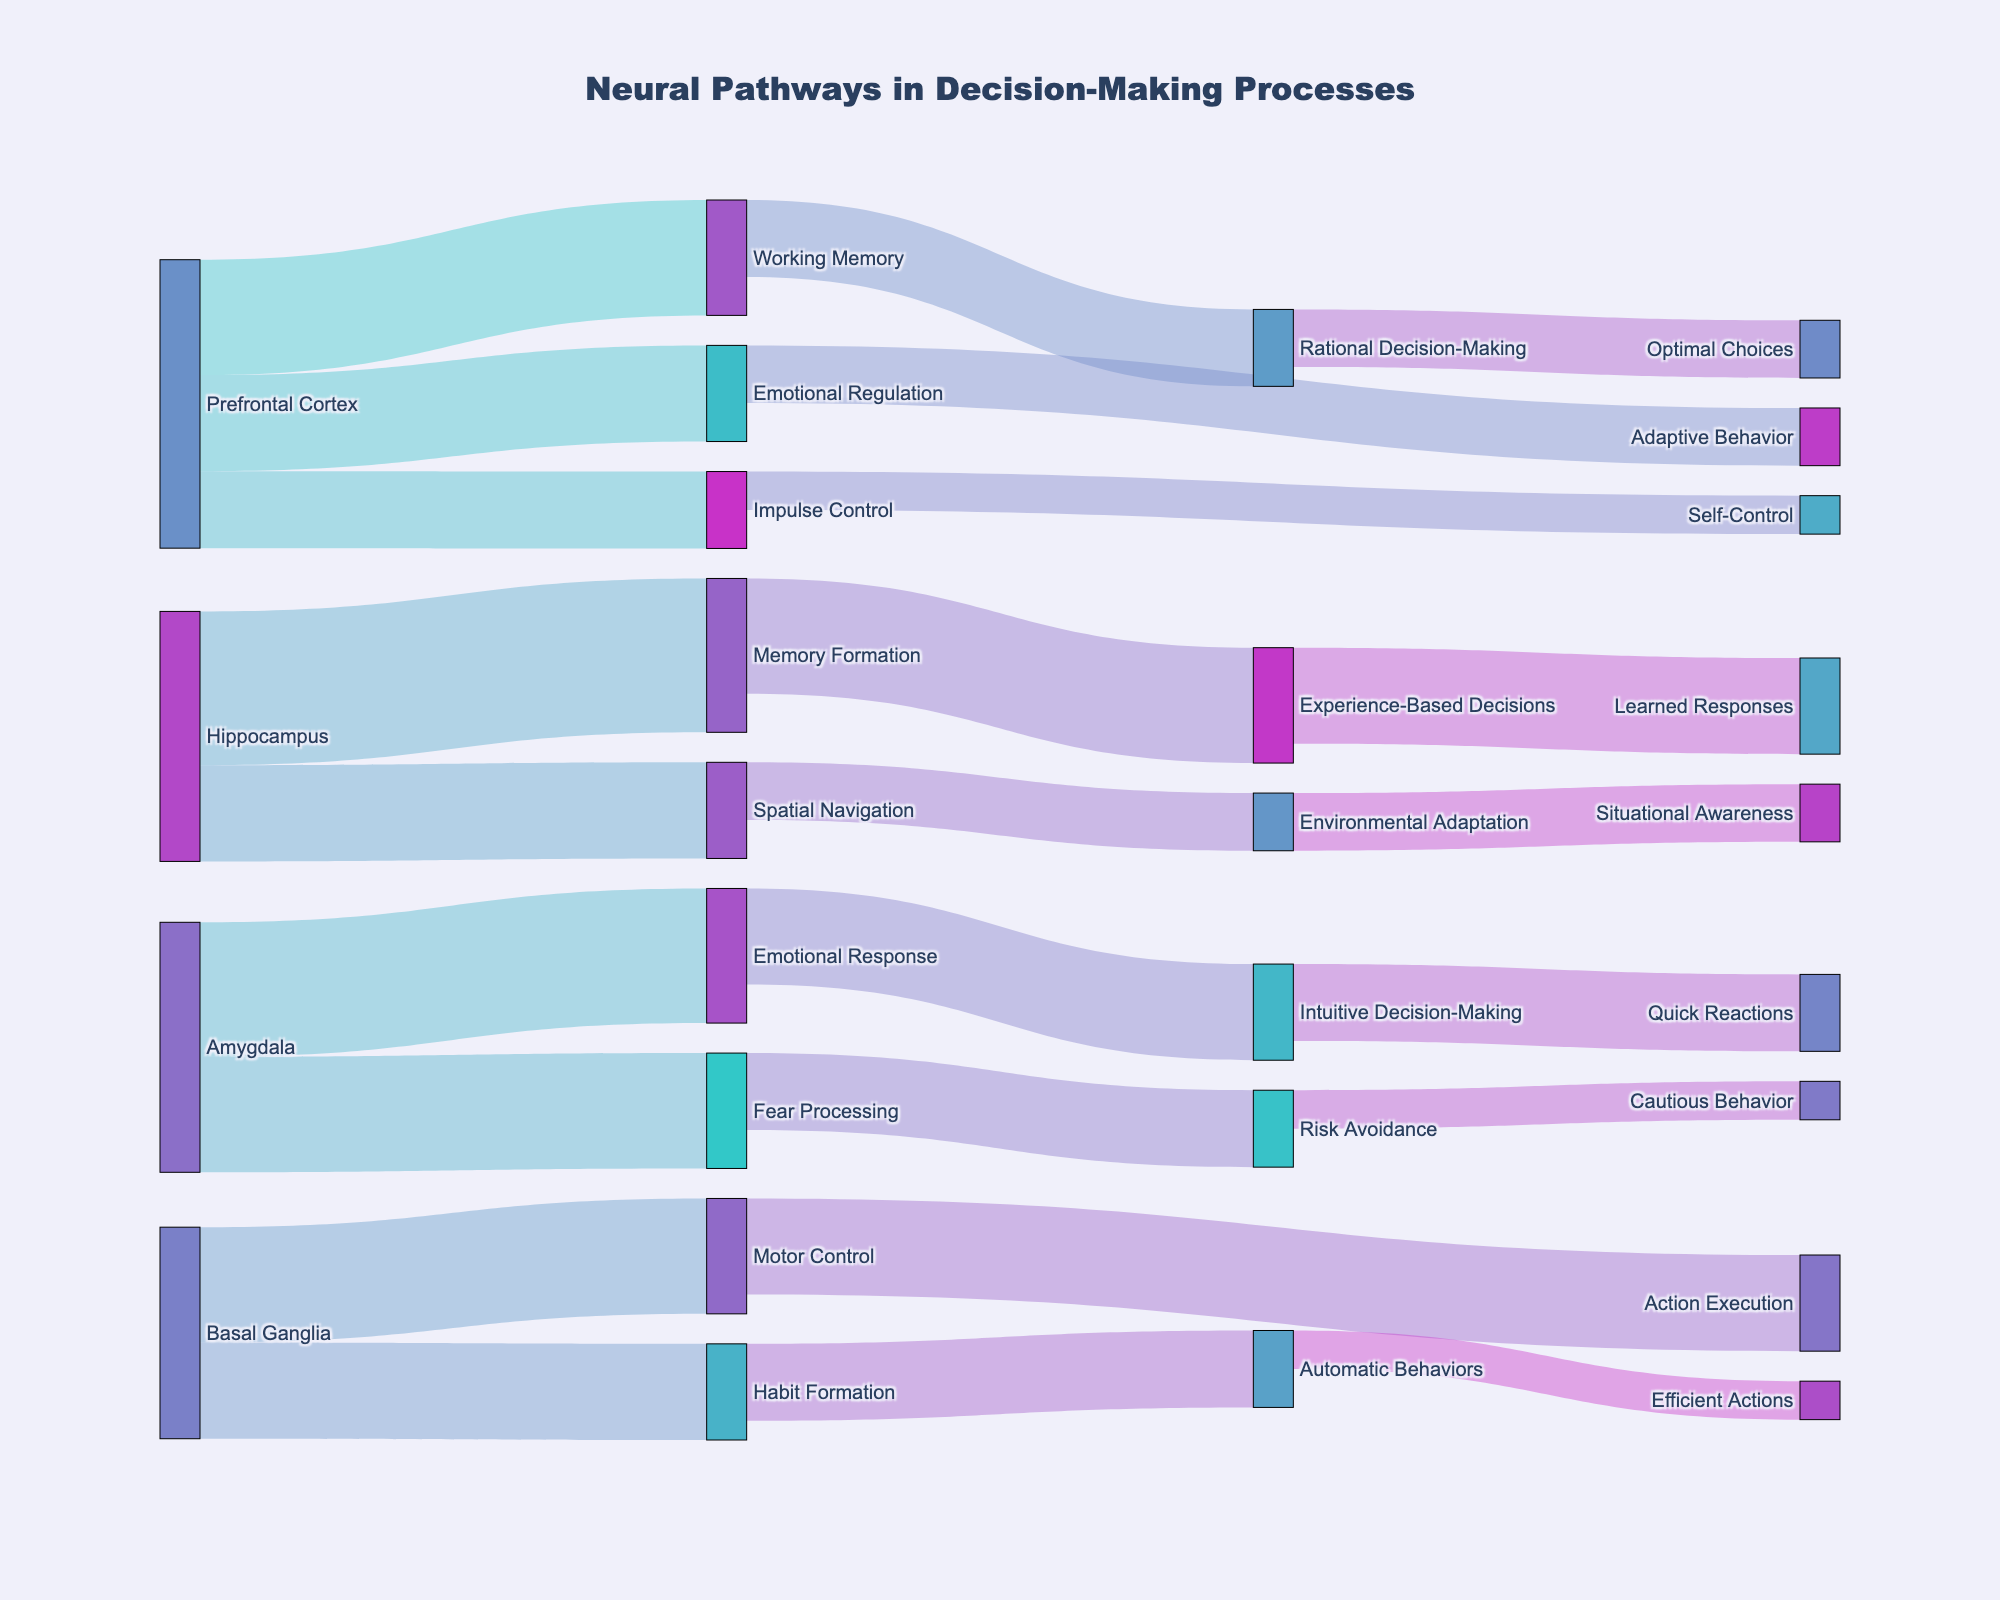where do the pathways of the Prefrontal Cortex lead? By looking at the connections starting from the Prefrontal Cortex, we can see arrows pointing to Working Memory, Emotional Regulation, and Impulse Control, indicating that these are the pathways from the Prefrontal Cortex.
Answer: Working Memory, Emotional Regulation, Impulse Control What is the total value of pathways originating from the Amygdala? Summing up the values of connections originating from the Amygdala (Emotional Response with 35 and Fear Processing with 30), we get a total.
Answer: 65 Which brain region is connected to Learned Responses? By following the pathway leading to Learned Responses, we trace back to Experience-Based Decisions, which is connected to Memory Formation in the Hippocampus.
Answer: Hippocampus How does Emotional Response influence decision-making? By tracing the pathway from Emotional Response, we see it connects to Intuitive Decision-Making, which in turn leads to Quick Reactions, illustrating an influence of Emotional Response on decision outcomes.
Answer: Intuitive Decision-Making, Quick Reactions What are the differences in value between pathways from the Prefrontal Cortex to Emotional Regulation and Impulse Control? The value of the pathway from the Prefrontal Cortex to Emotional Regulation is 25, and to Impulse Control is 20. The difference is found by subtracting 20 from 25.
Answer: 5 Which connection has the highest value? By comparing the values of all connections, the Memory Formation pathway from the Hippocampus stands out with the highest value of 40.
Answer: Memory Formation Are the values of pathways from the Basal Ganglia greater than those from the Prefrontal Cortex? Summing the values of pathways from the Basal Ganglia (30 for Motor Control and 25 for Habit Formation) gives 55, and doing the same for the Prefrontal Cortex (30 for Working Memory, 25 for Emotional Regulation, and 20 for Impulse Control) gives 75. Basal Ganglia's sum is less than the Prefrontal Cortex's sum.
Answer: No What brain region handles more pathways associated with different memory processes? Comparing the pathways connected to memory functions, the Hippocampus (Memory Formation, Spatial Navigation) manages more pathways related to memory compared to the Prefrontal Cortex (Working Memory) or any other brain region.
Answer: Hippocampus Which brain regions are involved in Adaptive and Efficient Behaviors? Tracing the connections to Adaptive Behavior, we see it is influenced by Emotional Regulation from the Prefrontal Cortex, while Efficient Actions are tied to Habit Formation in the Basal Ganglia.
Answer: Prefrontal Cortex, Basal Ganglia Which outcomes are influenced by both Rational Decision-Making and Intuitive Decision-Making? By following the pathways from Rational Decision-Making and Intuitive Decision-Making, we observe both leading to different outcomes: Rational Decision-Making results in Optimal Choices, while Intuitive Decision-Making leads to Quick Reactions. There are no shared paths between them.
Answer: None 